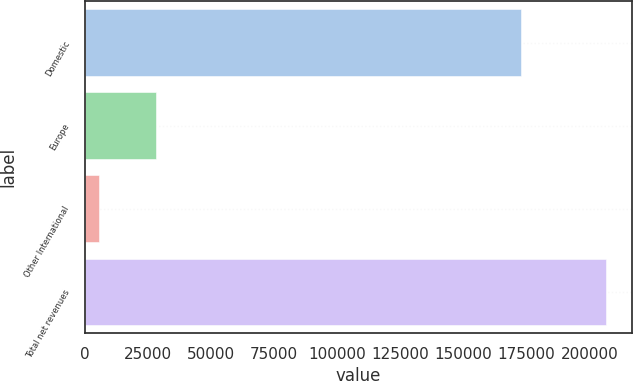Convert chart to OTSL. <chart><loc_0><loc_0><loc_500><loc_500><bar_chart><fcel>Domestic<fcel>Europe<fcel>Other International<fcel>Total net revenues<nl><fcel>172635<fcel>28076<fcel>5643<fcel>206354<nl></chart> 